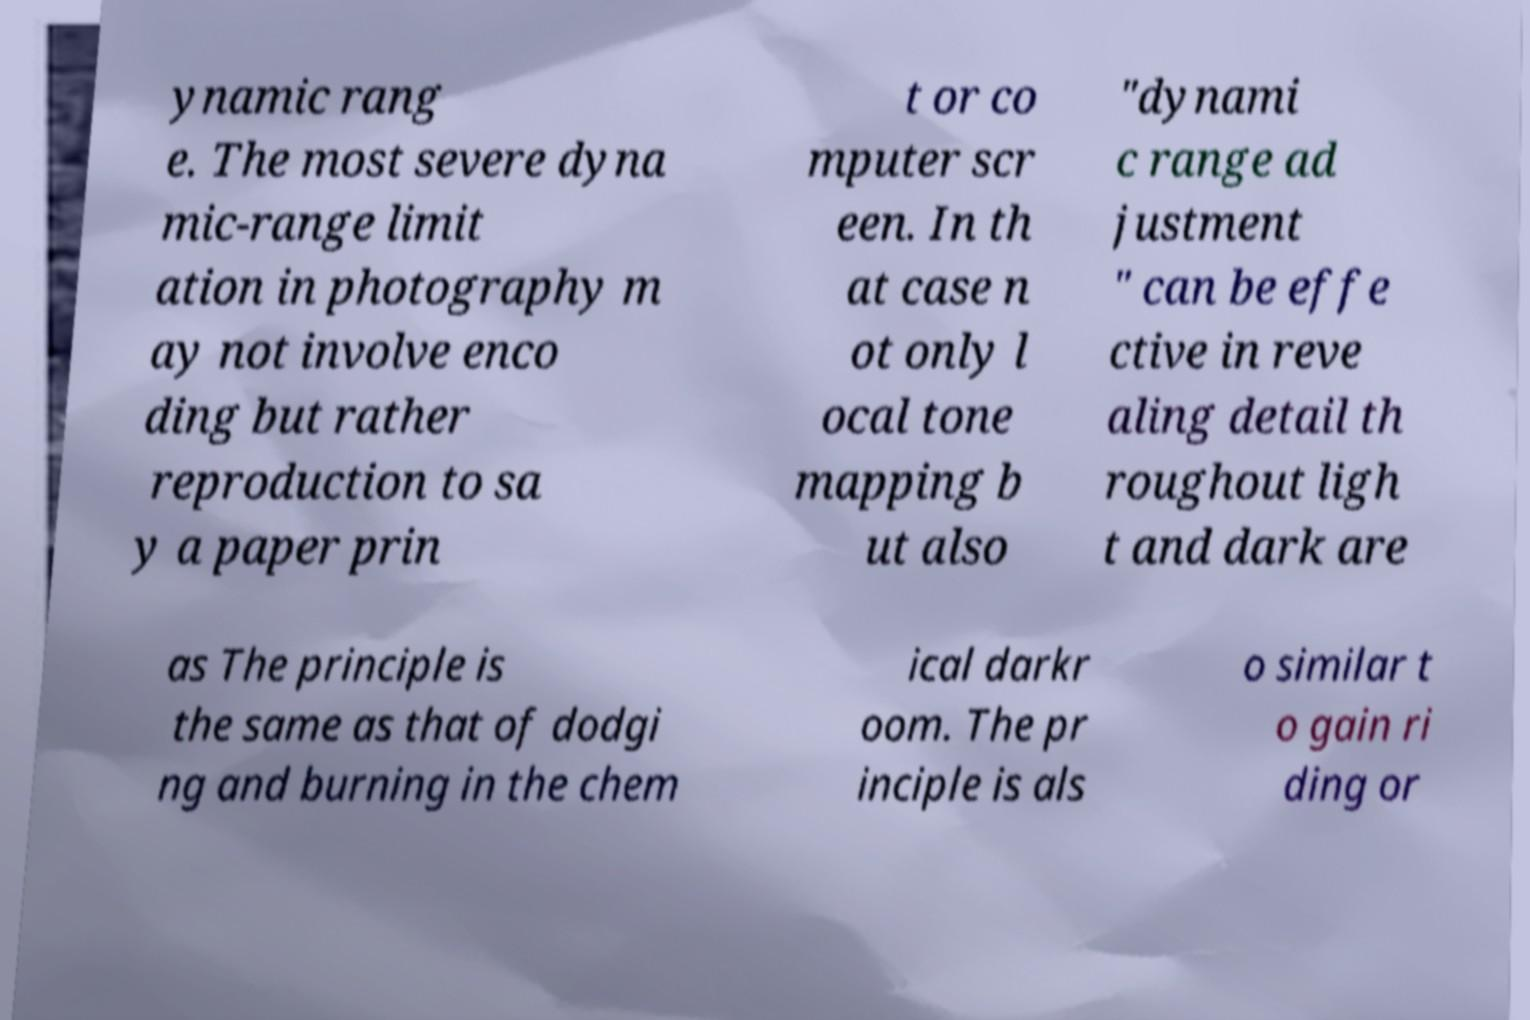Please read and relay the text visible in this image. What does it say? ynamic rang e. The most severe dyna mic-range limit ation in photography m ay not involve enco ding but rather reproduction to sa y a paper prin t or co mputer scr een. In th at case n ot only l ocal tone mapping b ut also "dynami c range ad justment " can be effe ctive in reve aling detail th roughout ligh t and dark are as The principle is the same as that of dodgi ng and burning in the chem ical darkr oom. The pr inciple is als o similar t o gain ri ding or 